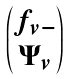Convert formula to latex. <formula><loc_0><loc_0><loc_500><loc_500>\begin{pmatrix} f _ { v - } \\ \Psi _ { v } \end{pmatrix}</formula> 